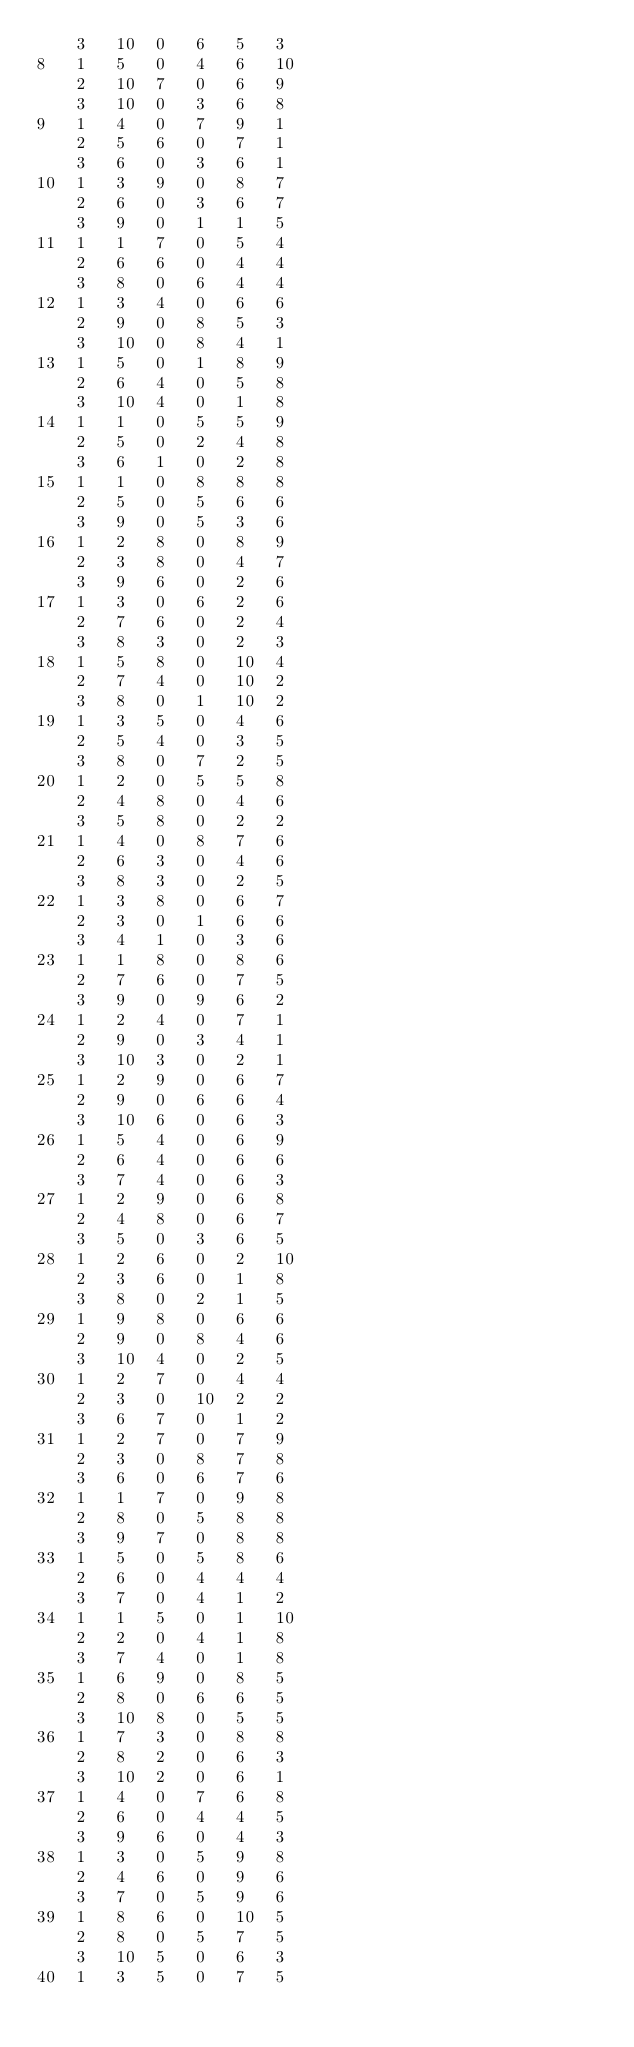<code> <loc_0><loc_0><loc_500><loc_500><_ObjectiveC_>	3	10	0	6	5	3	
8	1	5	0	4	6	10	
	2	10	7	0	6	9	
	3	10	0	3	6	8	
9	1	4	0	7	9	1	
	2	5	6	0	7	1	
	3	6	0	3	6	1	
10	1	3	9	0	8	7	
	2	6	0	3	6	7	
	3	9	0	1	1	5	
11	1	1	7	0	5	4	
	2	6	6	0	4	4	
	3	8	0	6	4	4	
12	1	3	4	0	6	6	
	2	9	0	8	5	3	
	3	10	0	8	4	1	
13	1	5	0	1	8	9	
	2	6	4	0	5	8	
	3	10	4	0	1	8	
14	1	1	0	5	5	9	
	2	5	0	2	4	8	
	3	6	1	0	2	8	
15	1	1	0	8	8	8	
	2	5	0	5	6	6	
	3	9	0	5	3	6	
16	1	2	8	0	8	9	
	2	3	8	0	4	7	
	3	9	6	0	2	6	
17	1	3	0	6	2	6	
	2	7	6	0	2	4	
	3	8	3	0	2	3	
18	1	5	8	0	10	4	
	2	7	4	0	10	2	
	3	8	0	1	10	2	
19	1	3	5	0	4	6	
	2	5	4	0	3	5	
	3	8	0	7	2	5	
20	1	2	0	5	5	8	
	2	4	8	0	4	6	
	3	5	8	0	2	2	
21	1	4	0	8	7	6	
	2	6	3	0	4	6	
	3	8	3	0	2	5	
22	1	3	8	0	6	7	
	2	3	0	1	6	6	
	3	4	1	0	3	6	
23	1	1	8	0	8	6	
	2	7	6	0	7	5	
	3	9	0	9	6	2	
24	1	2	4	0	7	1	
	2	9	0	3	4	1	
	3	10	3	0	2	1	
25	1	2	9	0	6	7	
	2	9	0	6	6	4	
	3	10	6	0	6	3	
26	1	5	4	0	6	9	
	2	6	4	0	6	6	
	3	7	4	0	6	3	
27	1	2	9	0	6	8	
	2	4	8	0	6	7	
	3	5	0	3	6	5	
28	1	2	6	0	2	10	
	2	3	6	0	1	8	
	3	8	0	2	1	5	
29	1	9	8	0	6	6	
	2	9	0	8	4	6	
	3	10	4	0	2	5	
30	1	2	7	0	4	4	
	2	3	0	10	2	2	
	3	6	7	0	1	2	
31	1	2	7	0	7	9	
	2	3	0	8	7	8	
	3	6	0	6	7	6	
32	1	1	7	0	9	8	
	2	8	0	5	8	8	
	3	9	7	0	8	8	
33	1	5	0	5	8	6	
	2	6	0	4	4	4	
	3	7	0	4	1	2	
34	1	1	5	0	1	10	
	2	2	0	4	1	8	
	3	7	4	0	1	8	
35	1	6	9	0	8	5	
	2	8	0	6	6	5	
	3	10	8	0	5	5	
36	1	7	3	0	8	8	
	2	8	2	0	6	3	
	3	10	2	0	6	1	
37	1	4	0	7	6	8	
	2	6	0	4	4	5	
	3	9	6	0	4	3	
38	1	3	0	5	9	8	
	2	4	6	0	9	6	
	3	7	0	5	9	6	
39	1	8	6	0	10	5	
	2	8	0	5	7	5	
	3	10	5	0	6	3	
40	1	3	5	0	7	5	</code> 